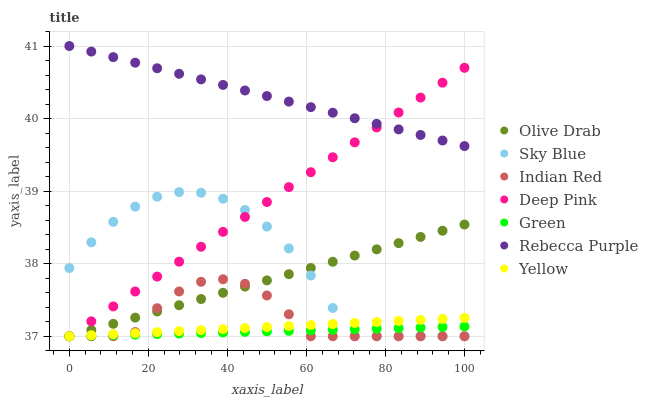Does Green have the minimum area under the curve?
Answer yes or no. Yes. Does Rebecca Purple have the maximum area under the curve?
Answer yes or no. Yes. Does Yellow have the minimum area under the curve?
Answer yes or no. No. Does Yellow have the maximum area under the curve?
Answer yes or no. No. Is Rebecca Purple the smoothest?
Answer yes or no. Yes. Is Indian Red the roughest?
Answer yes or no. Yes. Is Yellow the smoothest?
Answer yes or no. No. Is Yellow the roughest?
Answer yes or no. No. Does Deep Pink have the lowest value?
Answer yes or no. Yes. Does Rebecca Purple have the lowest value?
Answer yes or no. No. Does Rebecca Purple have the highest value?
Answer yes or no. Yes. Does Yellow have the highest value?
Answer yes or no. No. Is Sky Blue less than Rebecca Purple?
Answer yes or no. Yes. Is Rebecca Purple greater than Sky Blue?
Answer yes or no. Yes. Does Olive Drab intersect Deep Pink?
Answer yes or no. Yes. Is Olive Drab less than Deep Pink?
Answer yes or no. No. Is Olive Drab greater than Deep Pink?
Answer yes or no. No. Does Sky Blue intersect Rebecca Purple?
Answer yes or no. No. 